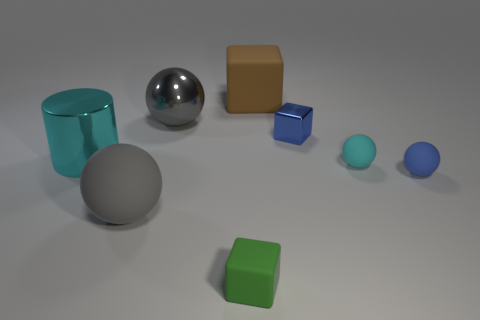Add 1 tiny rubber balls. How many objects exist? 9 Subtract all cylinders. How many objects are left? 7 Add 3 large matte things. How many large matte things are left? 5 Add 5 tiny cyan shiny cubes. How many tiny cyan shiny cubes exist? 5 Subtract 0 yellow balls. How many objects are left? 8 Subtract all cyan shiny cylinders. Subtract all blue shiny blocks. How many objects are left? 6 